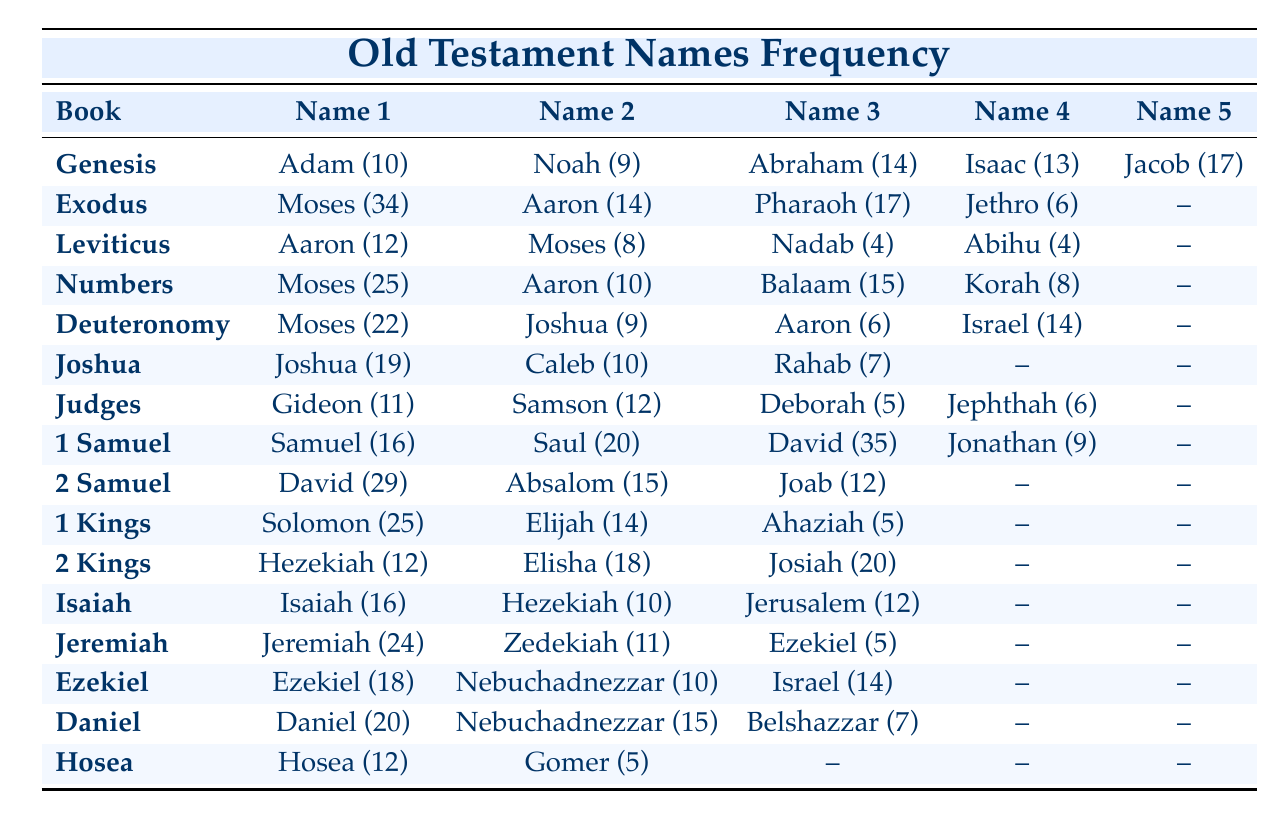What is the total number of times the name "Moses" is mentioned across the books? "Moses" appears in Exodus (34), Leviticus (8), Numbers (25), and Deuteronomy (22). Adding these values gives: 34 + 8 + 25 + 22 = 89.
Answer: 89 Which book mentions "David" the most? In 1 Samuel, "David" is mentioned 35 times, and in 2 Samuel, he is mentioned 29 times. Comparing the two, 35 > 29. Thus, 1 Samuel mentions "David" the most.
Answer: 1 Samuel How many names are mentioned in the book of "Judges"? The book of Judges mentions four names: Gideon, Samson, Deborah, and Jephthah.
Answer: 4 Is "Jeremiah" mentioned more often than "Zedekiah"? "Jeremiah" is mentioned 24 times, while "Zedekiah" is mentioned 11 times. Since 24 > 11, it is true that "Jeremiah" is mentioned more often.
Answer: Yes What is the average frequency of names mentioned in the book of "Exodus"? The names in Exodus are Moses (34), Aaron (14), Pharaoh (17), and Jethro (6). The total mentions are 34 + 14 + 17 + 6 = 71. There are 4 names, so the average is 71/4 = 17.75.
Answer: 17.75 Which name appears the second most in the Old Testament overall? From the data, the highest is "David" with 35 times in 1 Samuel, followed by "Moses" with 34 times in Exodus. Thus, "Moses" is the second most mentioned name overall.
Answer: Moses What is the sum of the mentions of "Abraham," "Jacob," and "Isaac" in Genesis? In Genesis, "Abraham" is mentioned 14 times, "Jacob" 17 times, and "Isaac" 13 times. Adding their mentions gives: 14 + 17 + 13 = 44.
Answer: 44 Does the name "Elijah" appear more than 15 times in the Old Testament? In 1 Kings, "Elijah" is mentioned 14 times. Since 14 is not greater than 15, the statement is false.
Answer: No 